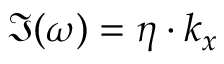Convert formula to latex. <formula><loc_0><loc_0><loc_500><loc_500>\Im ( \omega ) = \eta \cdot k _ { x }</formula> 